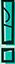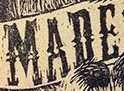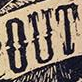Read the text content from these images in order, separated by a semicolon. !; MADE; OUT 